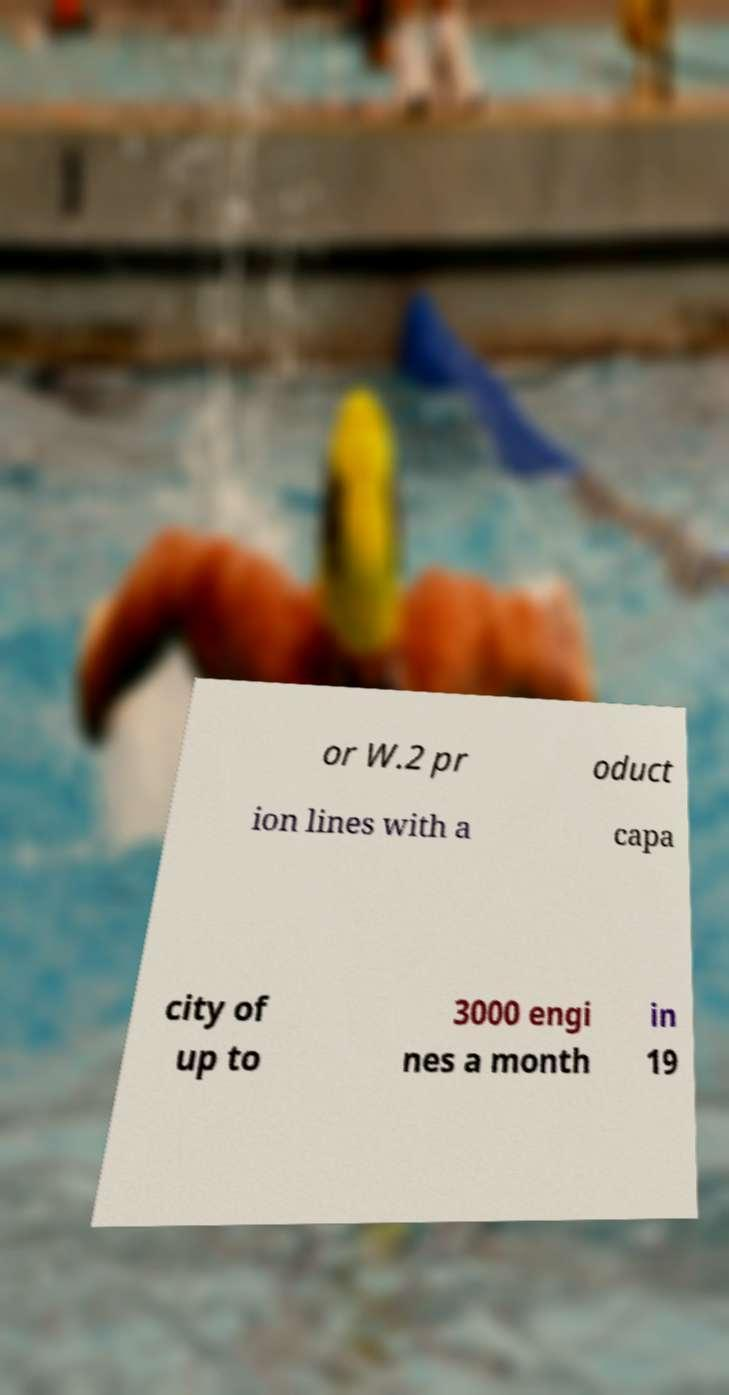Can you accurately transcribe the text from the provided image for me? or W.2 pr oduct ion lines with a capa city of up to 3000 engi nes a month in 19 